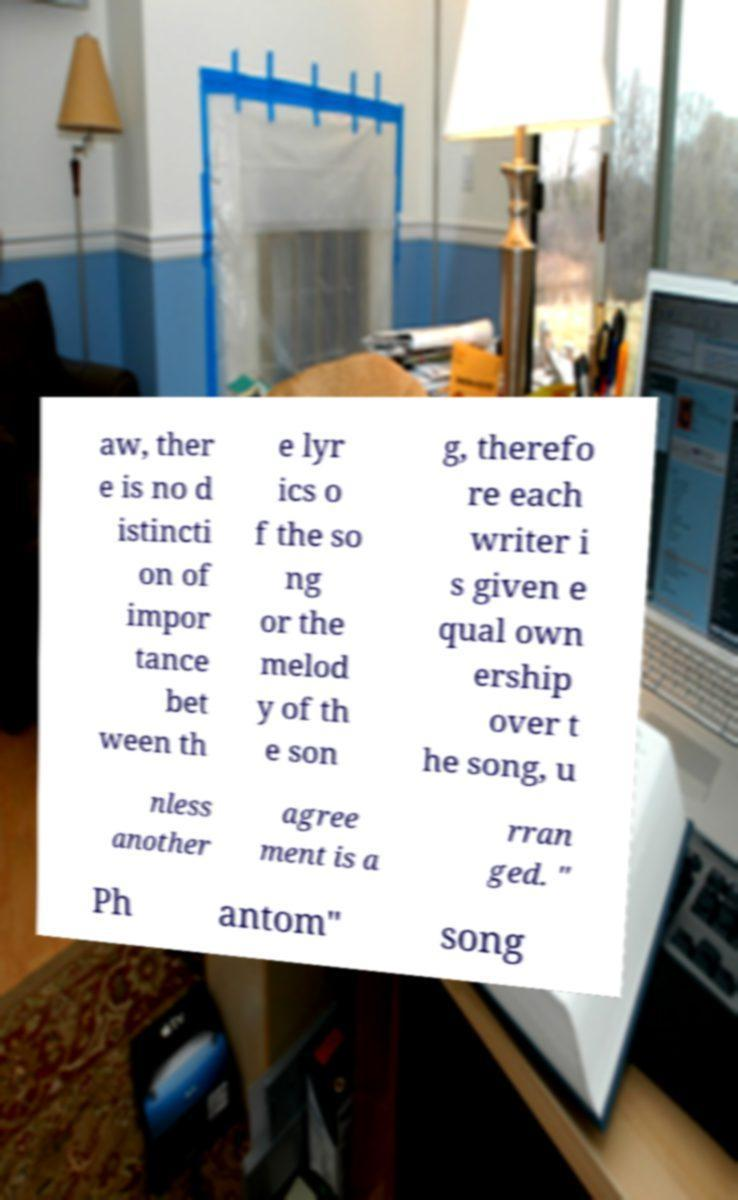I need the written content from this picture converted into text. Can you do that? aw, ther e is no d istincti on of impor tance bet ween th e lyr ics o f the so ng or the melod y of th e son g, therefo re each writer i s given e qual own ership over t he song, u nless another agree ment is a rran ged. " Ph antom" song 